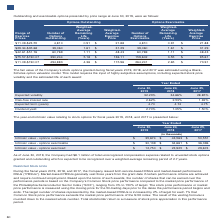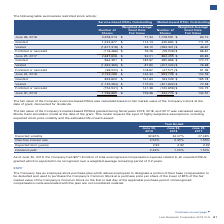According to Lam Research Corporation's financial document, How long do market-based PRSUs usually vest from grant date? According to the financial document, three years. The relevant text states: "RSUs (“PRSUs”). Market-based PRSUs generally vest three years from the grant date if certain performance criteria are achieved and require continued employment...." Also, How is the stock price performance or market price performance measured? using the closing price for the 50-trading days prior to the dates the performance period begins and ends. The document states: "rformance or market price performance is measured using the closing price for the 50-trading days prior to the dates the performance period begins and..." Also, What is the number of shares as of June 26, 2016? According to the financial document, 3,256,513. The relevant text states: "June 26, 2016 3,256,513 $ 71.34 1,078,591 $ 63.12..." Additionally, Which type of RSUs outstanding is higher as of June 26, 2016? Service-based RSUs Outstanding. The document states: "Service-based RSUs Outstanding Market-based RSUs Outstanding..." Additionally, Which type of RSUs outstanding is higher as of June 25, 2017? Service-based RSUs Outstanding. The document states: "Service-based RSUs Outstanding Market-based RSUs Outstanding..." Additionally, Which type of RSUs outstanding is higher as of June 30, 2019? Service-based RSUs Outstanding. The document states: "Service-based RSUs Outstanding Market-based RSUs Outstanding..." 